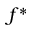<formula> <loc_0><loc_0><loc_500><loc_500>f ^ { * }</formula> 